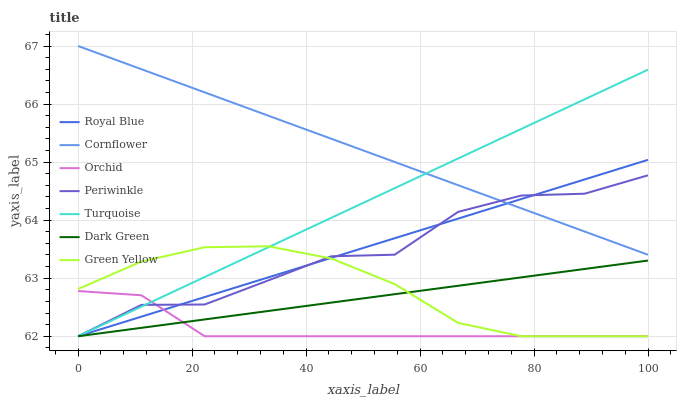Does Orchid have the minimum area under the curve?
Answer yes or no. Yes. Does Cornflower have the maximum area under the curve?
Answer yes or no. Yes. Does Turquoise have the minimum area under the curve?
Answer yes or no. No. Does Turquoise have the maximum area under the curve?
Answer yes or no. No. Is Royal Blue the smoothest?
Answer yes or no. Yes. Is Periwinkle the roughest?
Answer yes or no. Yes. Is Turquoise the smoothest?
Answer yes or no. No. Is Turquoise the roughest?
Answer yes or no. No. Does Turquoise have the lowest value?
Answer yes or no. Yes. Does Cornflower have the highest value?
Answer yes or no. Yes. Does Turquoise have the highest value?
Answer yes or no. No. Is Orchid less than Cornflower?
Answer yes or no. Yes. Is Cornflower greater than Dark Green?
Answer yes or no. Yes. Does Orchid intersect Turquoise?
Answer yes or no. Yes. Is Orchid less than Turquoise?
Answer yes or no. No. Is Orchid greater than Turquoise?
Answer yes or no. No. Does Orchid intersect Cornflower?
Answer yes or no. No. 